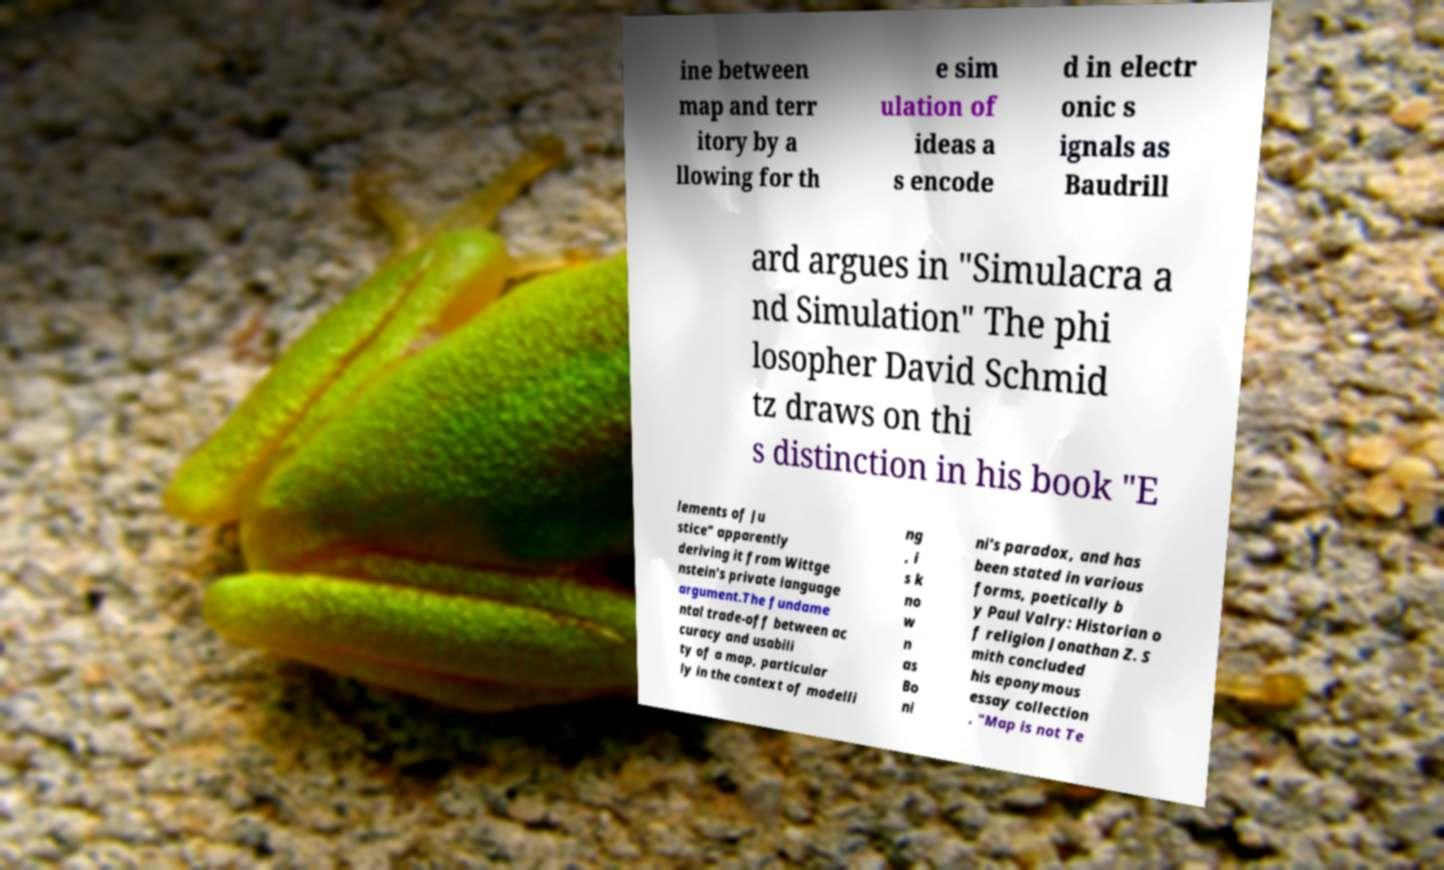Can you read and provide the text displayed in the image?This photo seems to have some interesting text. Can you extract and type it out for me? ine between map and terr itory by a llowing for th e sim ulation of ideas a s encode d in electr onic s ignals as Baudrill ard argues in "Simulacra a nd Simulation" The phi losopher David Schmid tz draws on thi s distinction in his book "E lements of Ju stice" apparently deriving it from Wittge nstein's private language argument.The fundame ntal trade-off between ac curacy and usabili ty of a map, particular ly in the context of modelli ng , i s k no w n as Bo ni ni's paradox, and has been stated in various forms, poetically b y Paul Valry: Historian o f religion Jonathan Z. S mith concluded his eponymous essay collection , "Map is not Te 